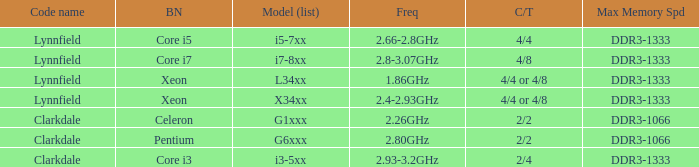What brand is model I7-8xx? Core i7. 